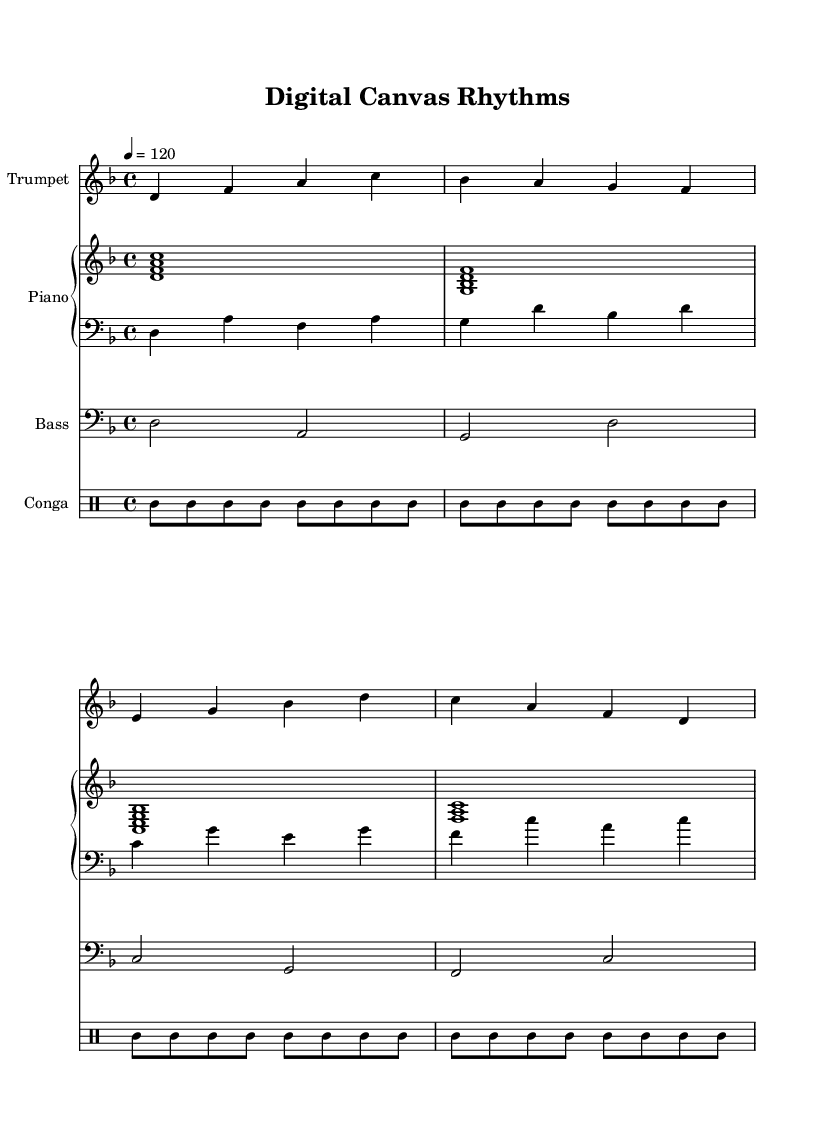What is the key signature of this music? The key signature is D minor, which has one flat (B flat).
Answer: D minor What is the time signature of the piece? The time signature is 4/4, indicating four beats per measure.
Answer: 4/4 What is the tempo marking given in the music? The tempo marking is 4 = 120, indicating the beats per minute.
Answer: 120 How many measures are in the trumpet melody? The trumpet melody consists of four measures, as indicated by the grouping of the bars.
Answer: 4 Which instrument plays the melodic line? The trumpet plays the melodic line, as indicated by the corresponding staff labeled "Trumpet."
Answer: Trumpet What is the rhythm pattern of the conga part? The conga rhythm pattern consists of two alternating rhythmic patterns, shown by the eighth notes and rests.
Answer: Alternating How does the piano left hand differ from the right hand? The piano left hand plays single notes while the right hand plays chords, as shown in the respective staves.
Answer: Chords vs. single notes 